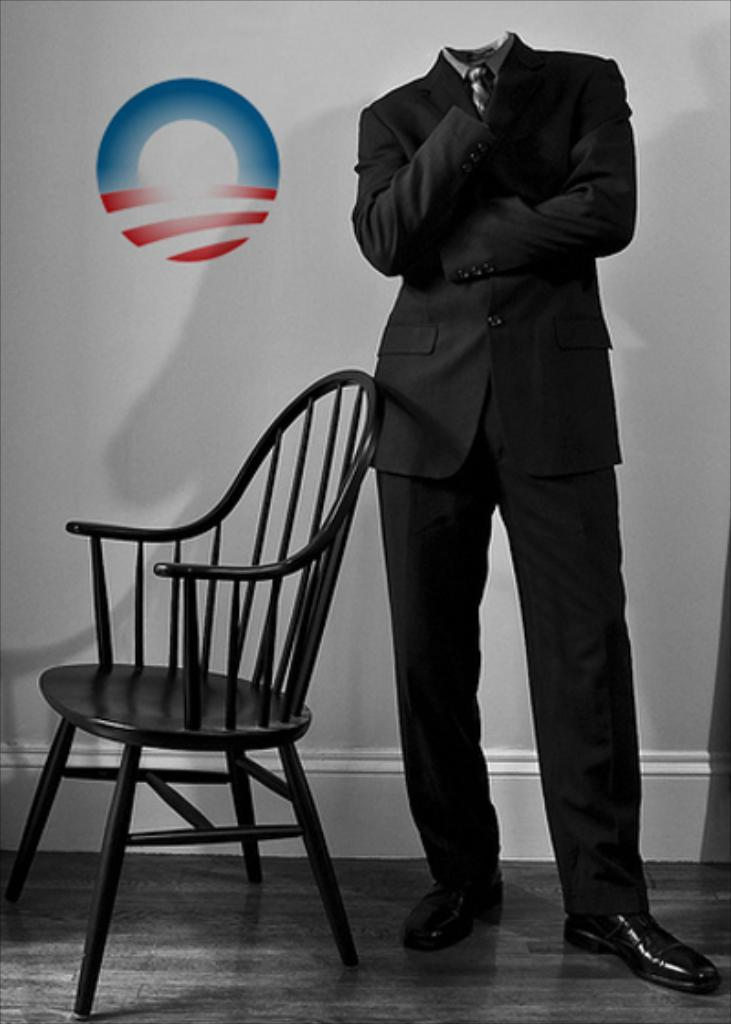What is the person in the image holding? The person is holding a phone. What color is the phone? The phone is black in color. What type of skin is visible on the phone in the image? The image does not show any skin on the phone, as it is a black phone being held by a person. 